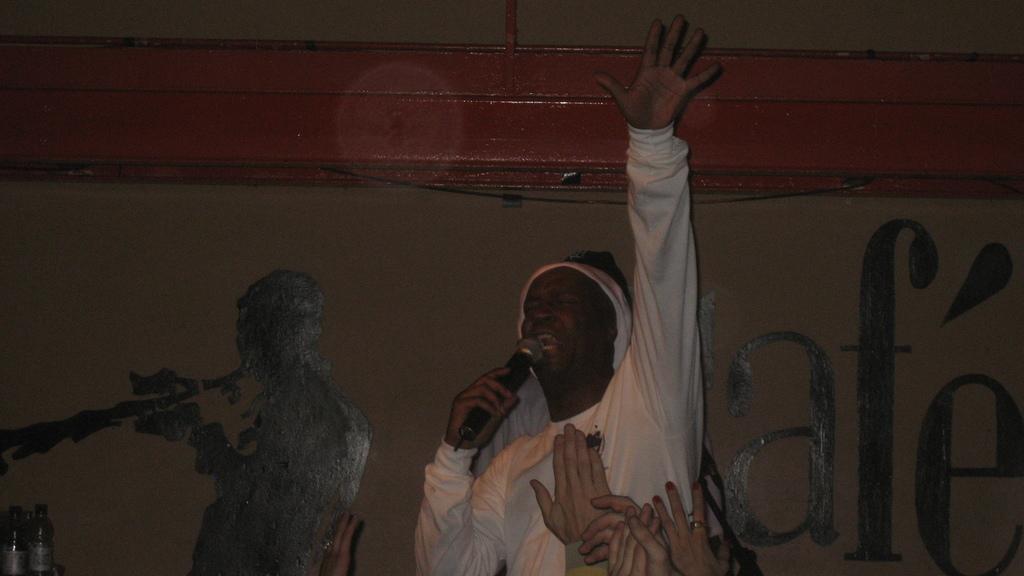Please provide a concise description of this image. In the center of the image there is a person wearing a white color t-shirt and holding a mic. In the background of the image there is wall. 